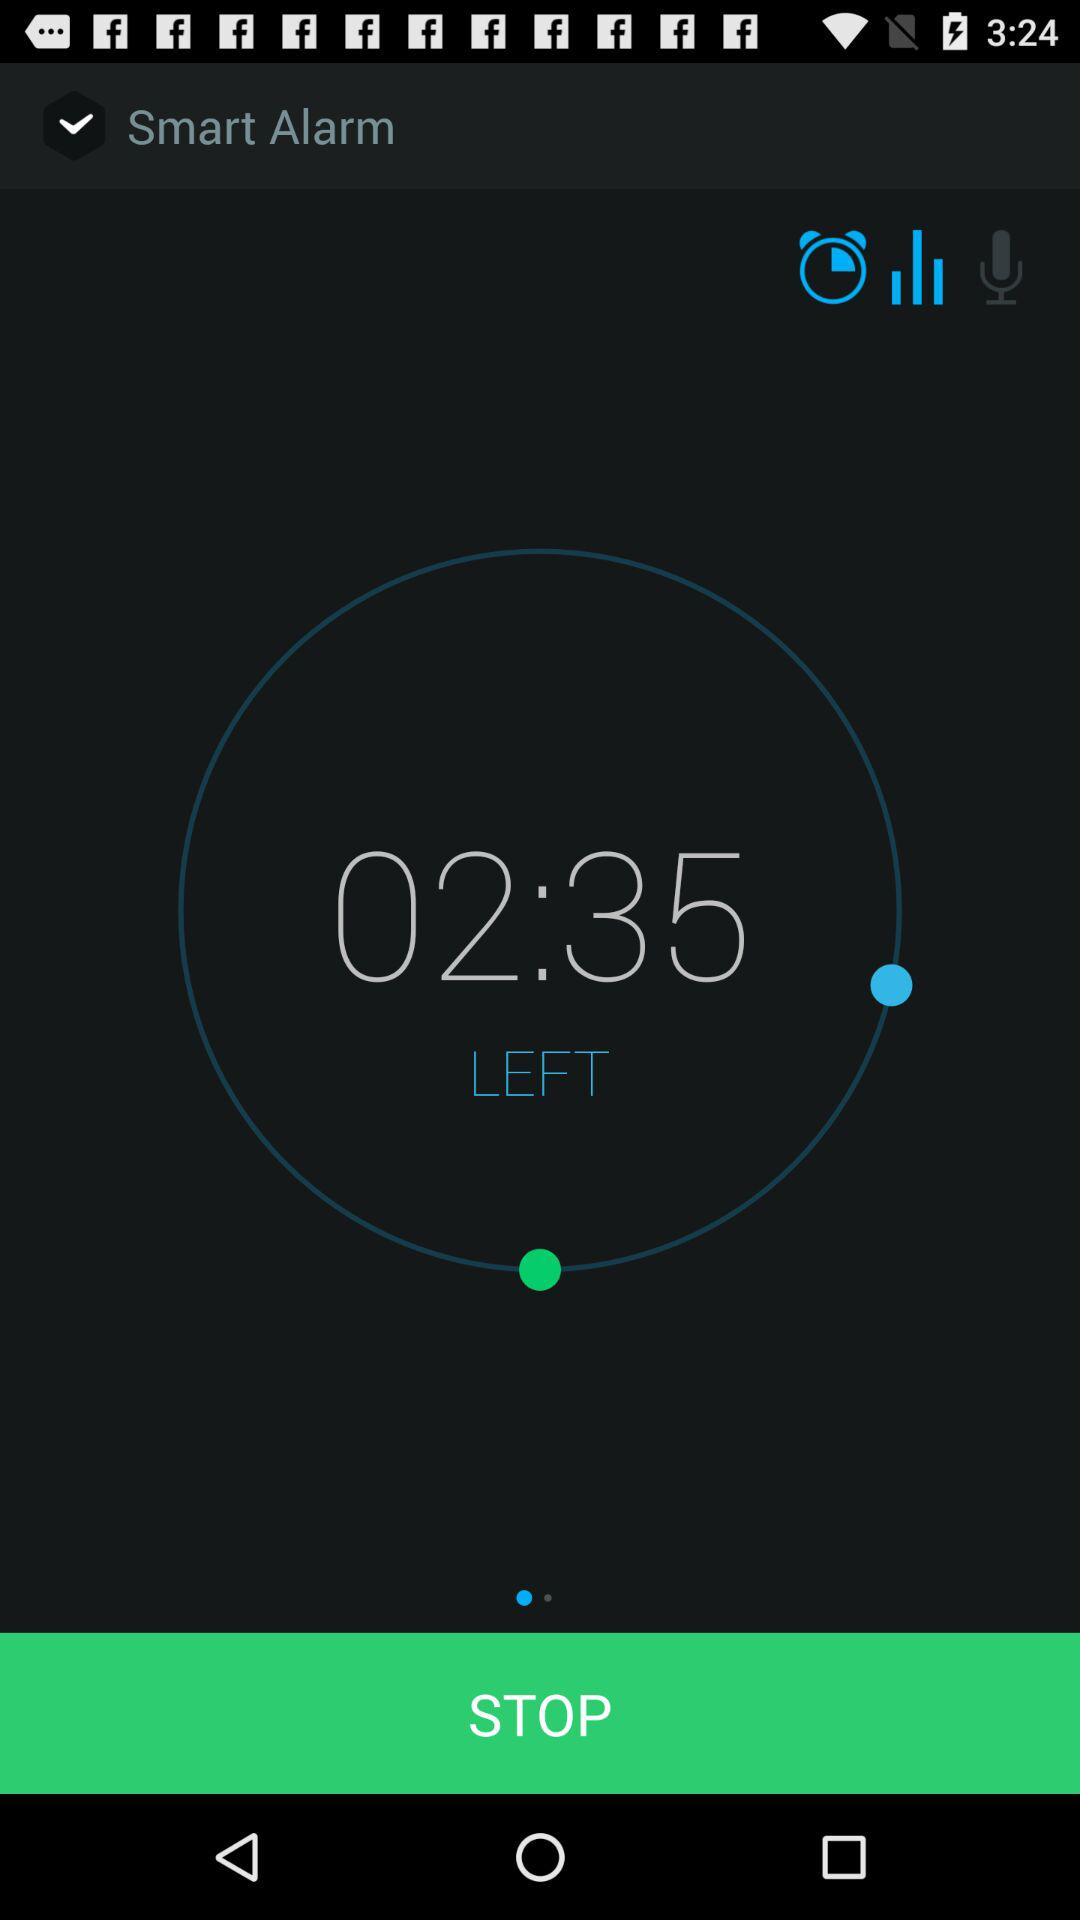For which days is the alarm set?
When the provided information is insufficient, respond with <no answer>. <no answer> 